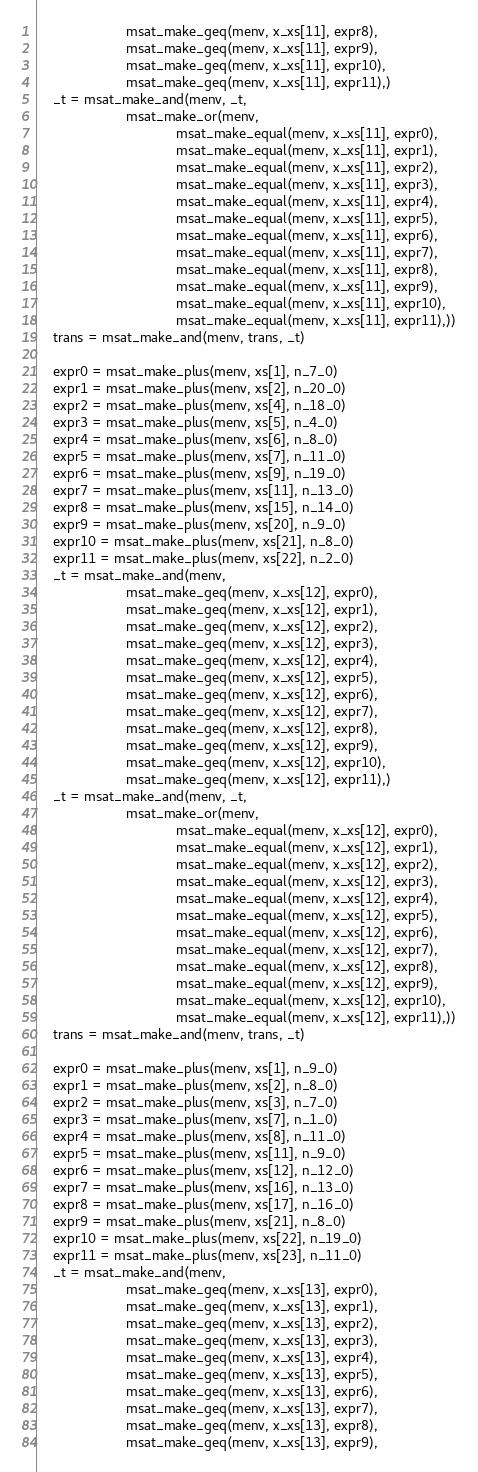<code> <loc_0><loc_0><loc_500><loc_500><_Python_>                       msat_make_geq(menv, x_xs[11], expr8),
                       msat_make_geq(menv, x_xs[11], expr9),
                       msat_make_geq(menv, x_xs[11], expr10),
                       msat_make_geq(menv, x_xs[11], expr11),)
    _t = msat_make_and(menv, _t,
                       msat_make_or(menv,
                                    msat_make_equal(menv, x_xs[11], expr0),
                                    msat_make_equal(menv, x_xs[11], expr1),
                                    msat_make_equal(menv, x_xs[11], expr2),
                                    msat_make_equal(menv, x_xs[11], expr3),
                                    msat_make_equal(menv, x_xs[11], expr4),
                                    msat_make_equal(menv, x_xs[11], expr5),
                                    msat_make_equal(menv, x_xs[11], expr6),
                                    msat_make_equal(menv, x_xs[11], expr7),
                                    msat_make_equal(menv, x_xs[11], expr8),
                                    msat_make_equal(menv, x_xs[11], expr9),
                                    msat_make_equal(menv, x_xs[11], expr10),
                                    msat_make_equal(menv, x_xs[11], expr11),))
    trans = msat_make_and(menv, trans, _t)

    expr0 = msat_make_plus(menv, xs[1], n_7_0)
    expr1 = msat_make_plus(menv, xs[2], n_20_0)
    expr2 = msat_make_plus(menv, xs[4], n_18_0)
    expr3 = msat_make_plus(menv, xs[5], n_4_0)
    expr4 = msat_make_plus(menv, xs[6], n_8_0)
    expr5 = msat_make_plus(menv, xs[7], n_11_0)
    expr6 = msat_make_plus(menv, xs[9], n_19_0)
    expr7 = msat_make_plus(menv, xs[11], n_13_0)
    expr8 = msat_make_plus(menv, xs[15], n_14_0)
    expr9 = msat_make_plus(menv, xs[20], n_9_0)
    expr10 = msat_make_plus(menv, xs[21], n_8_0)
    expr11 = msat_make_plus(menv, xs[22], n_2_0)
    _t = msat_make_and(menv,
                       msat_make_geq(menv, x_xs[12], expr0),
                       msat_make_geq(menv, x_xs[12], expr1),
                       msat_make_geq(menv, x_xs[12], expr2),
                       msat_make_geq(menv, x_xs[12], expr3),
                       msat_make_geq(menv, x_xs[12], expr4),
                       msat_make_geq(menv, x_xs[12], expr5),
                       msat_make_geq(menv, x_xs[12], expr6),
                       msat_make_geq(menv, x_xs[12], expr7),
                       msat_make_geq(menv, x_xs[12], expr8),
                       msat_make_geq(menv, x_xs[12], expr9),
                       msat_make_geq(menv, x_xs[12], expr10),
                       msat_make_geq(menv, x_xs[12], expr11),)
    _t = msat_make_and(menv, _t,
                       msat_make_or(menv,
                                    msat_make_equal(menv, x_xs[12], expr0),
                                    msat_make_equal(menv, x_xs[12], expr1),
                                    msat_make_equal(menv, x_xs[12], expr2),
                                    msat_make_equal(menv, x_xs[12], expr3),
                                    msat_make_equal(menv, x_xs[12], expr4),
                                    msat_make_equal(menv, x_xs[12], expr5),
                                    msat_make_equal(menv, x_xs[12], expr6),
                                    msat_make_equal(menv, x_xs[12], expr7),
                                    msat_make_equal(menv, x_xs[12], expr8),
                                    msat_make_equal(menv, x_xs[12], expr9),
                                    msat_make_equal(menv, x_xs[12], expr10),
                                    msat_make_equal(menv, x_xs[12], expr11),))
    trans = msat_make_and(menv, trans, _t)

    expr0 = msat_make_plus(menv, xs[1], n_9_0)
    expr1 = msat_make_plus(menv, xs[2], n_8_0)
    expr2 = msat_make_plus(menv, xs[3], n_7_0)
    expr3 = msat_make_plus(menv, xs[7], n_1_0)
    expr4 = msat_make_plus(menv, xs[8], n_11_0)
    expr5 = msat_make_plus(menv, xs[11], n_9_0)
    expr6 = msat_make_plus(menv, xs[12], n_12_0)
    expr7 = msat_make_plus(menv, xs[16], n_13_0)
    expr8 = msat_make_plus(menv, xs[17], n_16_0)
    expr9 = msat_make_plus(menv, xs[21], n_8_0)
    expr10 = msat_make_plus(menv, xs[22], n_19_0)
    expr11 = msat_make_plus(menv, xs[23], n_11_0)
    _t = msat_make_and(menv,
                       msat_make_geq(menv, x_xs[13], expr0),
                       msat_make_geq(menv, x_xs[13], expr1),
                       msat_make_geq(menv, x_xs[13], expr2),
                       msat_make_geq(menv, x_xs[13], expr3),
                       msat_make_geq(menv, x_xs[13], expr4),
                       msat_make_geq(menv, x_xs[13], expr5),
                       msat_make_geq(menv, x_xs[13], expr6),
                       msat_make_geq(menv, x_xs[13], expr7),
                       msat_make_geq(menv, x_xs[13], expr8),
                       msat_make_geq(menv, x_xs[13], expr9),</code> 